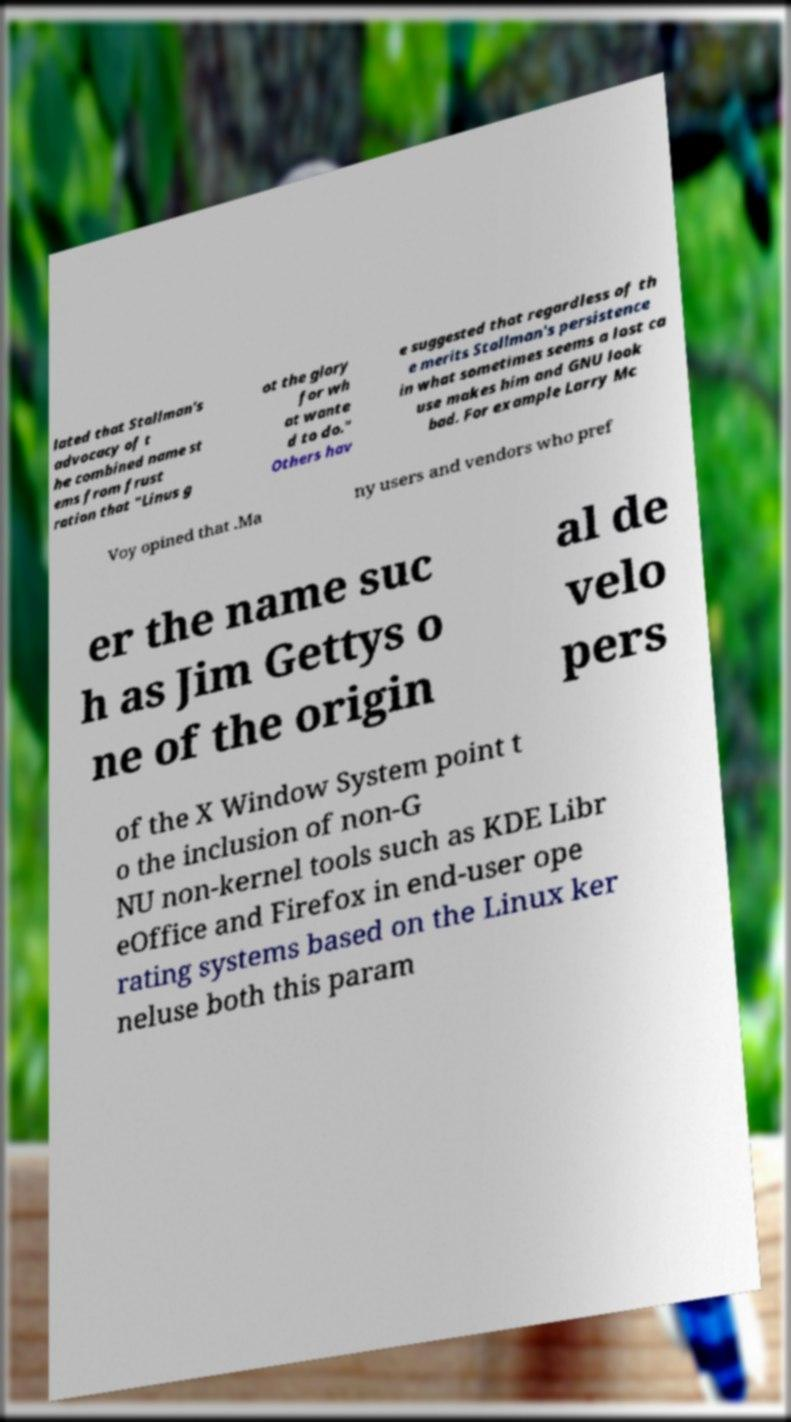Could you assist in decoding the text presented in this image and type it out clearly? lated that Stallman's advocacy of t he combined name st ems from frust ration that "Linus g ot the glory for wh at wante d to do." Others hav e suggested that regardless of th e merits Stallman's persistence in what sometimes seems a lost ca use makes him and GNU look bad. For example Larry Mc Voy opined that .Ma ny users and vendors who pref er the name suc h as Jim Gettys o ne of the origin al de velo pers of the X Window System point t o the inclusion of non-G NU non-kernel tools such as KDE Libr eOffice and Firefox in end-user ope rating systems based on the Linux ker neluse both this param 